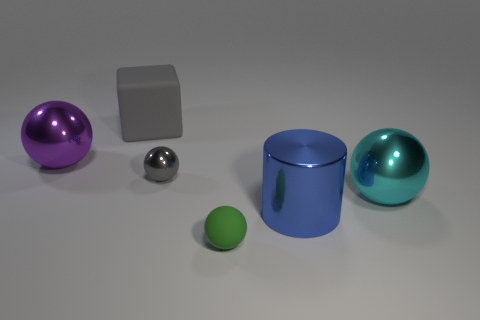What number of spheres are behind the tiny matte object and right of the big rubber thing?
Make the answer very short. 2. What color is the large sphere behind the large metal ball right of the purple shiny thing?
Offer a terse response. Purple. Are there the same number of tiny things that are left of the purple shiny object and small objects?
Give a very brief answer. No. There is a cylinder in front of the large sphere to the left of the big cyan shiny thing; how many objects are behind it?
Your answer should be very brief. 4. What is the color of the large sphere on the left side of the cyan object?
Your answer should be compact. Purple. The thing that is in front of the cyan shiny object and behind the green matte object is made of what material?
Provide a succinct answer. Metal. There is a thing that is to the left of the big cube; what number of small green objects are in front of it?
Keep it short and to the point. 1. What is the shape of the big cyan metal object?
Provide a short and direct response. Sphere. There is a purple thing that is made of the same material as the big cyan thing; what shape is it?
Offer a very short reply. Sphere. There is a metallic thing that is to the left of the tiny shiny object; is it the same shape as the tiny rubber object?
Keep it short and to the point. Yes. 